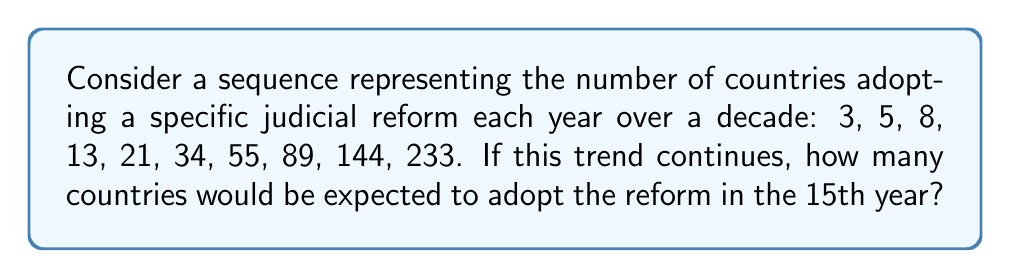Provide a solution to this math problem. 1) First, let's analyze the given sequence:
   3, 5, 8, 13, 21, 34, 55, 89, 144, 233

2) We can observe that each term is the sum of the two preceding terms:
   5 = 3 + 2
   8 = 5 + 3
   13 = 8 + 5
   ...and so on.

3) This pattern is known as the Fibonacci sequence, defined by the recurrence relation:
   $$F_n = F_{n-1} + F_{n-2}$$
   where $F_n$ is the nth term of the sequence.

4) To find the 15th term, we need to continue the sequence for 5 more terms:
   11th term: 233 + 144 = 377
   12th term: 377 + 233 = 610
   13th term: 610 + 377 = 987
   14th term: 987 + 610 = 1597
   15th term: 1597 + 987 = 2584

5) Alternatively, we could use the closed-form expression for the nth Fibonacci number:
   $$F_n = \frac{\phi^n - (-\phi)^{-n}}{\sqrt{5}}$$
   where $\phi = \frac{1 + \sqrt{5}}{2}$ is the golden ratio.

6) Plugging in n = 15:
   $$F_{15} = \frac{(\frac{1 + \sqrt{5}}{2})^{15} - (-\frac{1 + \sqrt{5}}{2})^{-15}}{\sqrt{5}} \approx 2584.0$$

7) Both methods yield the same result: 2584.
Answer: 2584 